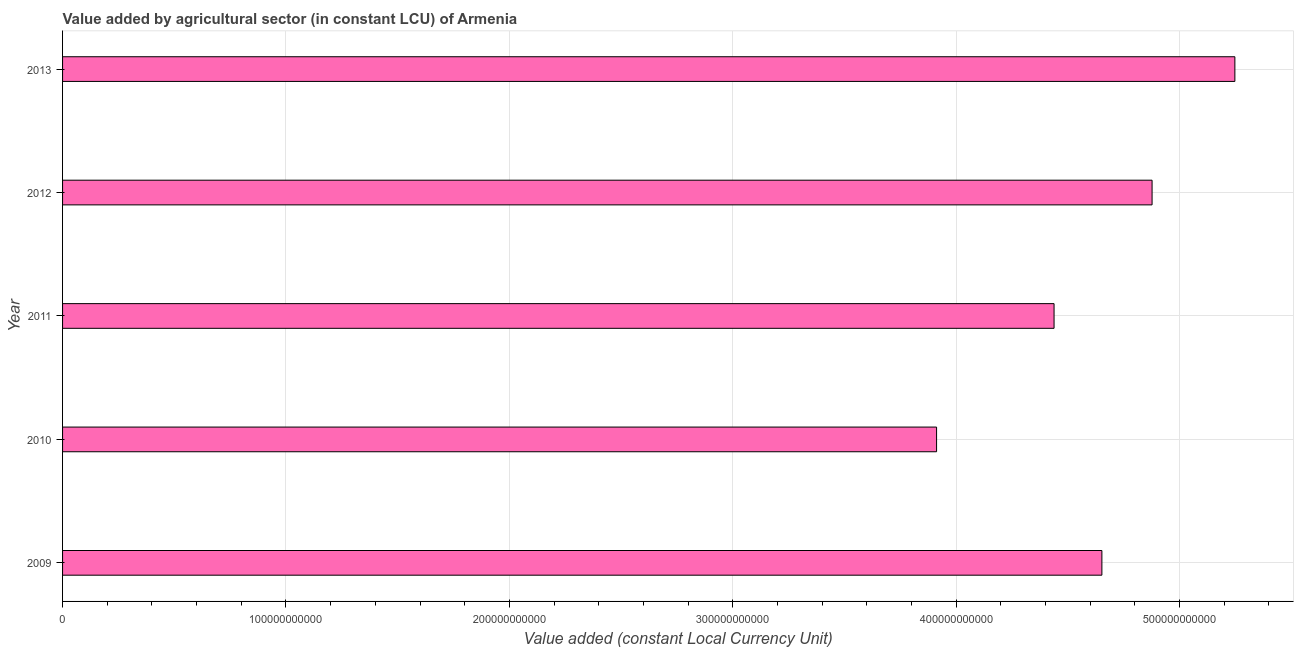Does the graph contain grids?
Provide a short and direct response. Yes. What is the title of the graph?
Give a very brief answer. Value added by agricultural sector (in constant LCU) of Armenia. What is the label or title of the X-axis?
Provide a succinct answer. Value added (constant Local Currency Unit). What is the value added by agriculture sector in 2010?
Keep it short and to the point. 3.91e+11. Across all years, what is the maximum value added by agriculture sector?
Offer a terse response. 5.25e+11. Across all years, what is the minimum value added by agriculture sector?
Offer a very short reply. 3.91e+11. In which year was the value added by agriculture sector minimum?
Provide a succinct answer. 2010. What is the sum of the value added by agriculture sector?
Your response must be concise. 2.31e+12. What is the difference between the value added by agriculture sector in 2010 and 2013?
Keep it short and to the point. -1.34e+11. What is the average value added by agriculture sector per year?
Your answer should be very brief. 4.63e+11. What is the median value added by agriculture sector?
Offer a terse response. 4.65e+11. In how many years, is the value added by agriculture sector greater than 460000000000 LCU?
Provide a succinct answer. 3. Do a majority of the years between 2011 and 2013 (inclusive) have value added by agriculture sector greater than 80000000000 LCU?
Provide a short and direct response. Yes. What is the ratio of the value added by agriculture sector in 2011 to that in 2012?
Offer a very short reply. 0.91. Is the value added by agriculture sector in 2009 less than that in 2011?
Your answer should be very brief. No. What is the difference between the highest and the second highest value added by agriculture sector?
Your answer should be compact. 3.71e+1. What is the difference between the highest and the lowest value added by agriculture sector?
Your response must be concise. 1.34e+11. In how many years, is the value added by agriculture sector greater than the average value added by agriculture sector taken over all years?
Give a very brief answer. 3. How many bars are there?
Your response must be concise. 5. How many years are there in the graph?
Offer a very short reply. 5. What is the difference between two consecutive major ticks on the X-axis?
Make the answer very short. 1.00e+11. What is the Value added (constant Local Currency Unit) in 2009?
Ensure brevity in your answer.  4.65e+11. What is the Value added (constant Local Currency Unit) in 2010?
Your response must be concise. 3.91e+11. What is the Value added (constant Local Currency Unit) of 2011?
Keep it short and to the point. 4.44e+11. What is the Value added (constant Local Currency Unit) in 2012?
Keep it short and to the point. 4.88e+11. What is the Value added (constant Local Currency Unit) in 2013?
Provide a short and direct response. 5.25e+11. What is the difference between the Value added (constant Local Currency Unit) in 2009 and 2010?
Keep it short and to the point. 7.40e+1. What is the difference between the Value added (constant Local Currency Unit) in 2009 and 2011?
Offer a terse response. 2.14e+1. What is the difference between the Value added (constant Local Currency Unit) in 2009 and 2012?
Offer a terse response. -2.25e+1. What is the difference between the Value added (constant Local Currency Unit) in 2009 and 2013?
Offer a very short reply. -5.95e+1. What is the difference between the Value added (constant Local Currency Unit) in 2010 and 2011?
Make the answer very short. -5.26e+1. What is the difference between the Value added (constant Local Currency Unit) in 2010 and 2012?
Offer a terse response. -9.65e+1. What is the difference between the Value added (constant Local Currency Unit) in 2010 and 2013?
Your answer should be compact. -1.34e+11. What is the difference between the Value added (constant Local Currency Unit) in 2011 and 2012?
Provide a succinct answer. -4.39e+1. What is the difference between the Value added (constant Local Currency Unit) in 2011 and 2013?
Ensure brevity in your answer.  -8.09e+1. What is the difference between the Value added (constant Local Currency Unit) in 2012 and 2013?
Keep it short and to the point. -3.71e+1. What is the ratio of the Value added (constant Local Currency Unit) in 2009 to that in 2010?
Your answer should be compact. 1.19. What is the ratio of the Value added (constant Local Currency Unit) in 2009 to that in 2011?
Make the answer very short. 1.05. What is the ratio of the Value added (constant Local Currency Unit) in 2009 to that in 2012?
Your answer should be very brief. 0.95. What is the ratio of the Value added (constant Local Currency Unit) in 2009 to that in 2013?
Your answer should be very brief. 0.89. What is the ratio of the Value added (constant Local Currency Unit) in 2010 to that in 2011?
Your answer should be compact. 0.88. What is the ratio of the Value added (constant Local Currency Unit) in 2010 to that in 2012?
Ensure brevity in your answer.  0.8. What is the ratio of the Value added (constant Local Currency Unit) in 2010 to that in 2013?
Provide a short and direct response. 0.75. What is the ratio of the Value added (constant Local Currency Unit) in 2011 to that in 2012?
Make the answer very short. 0.91. What is the ratio of the Value added (constant Local Currency Unit) in 2011 to that in 2013?
Your answer should be very brief. 0.85. What is the ratio of the Value added (constant Local Currency Unit) in 2012 to that in 2013?
Provide a short and direct response. 0.93. 